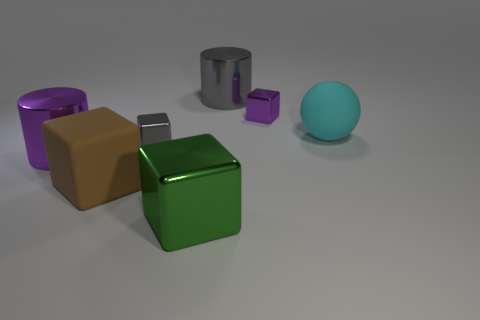Can you describe the shapes and their colors that are present in this image? Certainly! The image features a collection of geometric shapes including two cylinders, one large and gray and the other large and purple. There's also a set of cubes; a large brown one and a smaller, reflective silver cube. Additionally, there's a large green cube and a small purple cube. Lastly, there's a teal-colored sphere. 